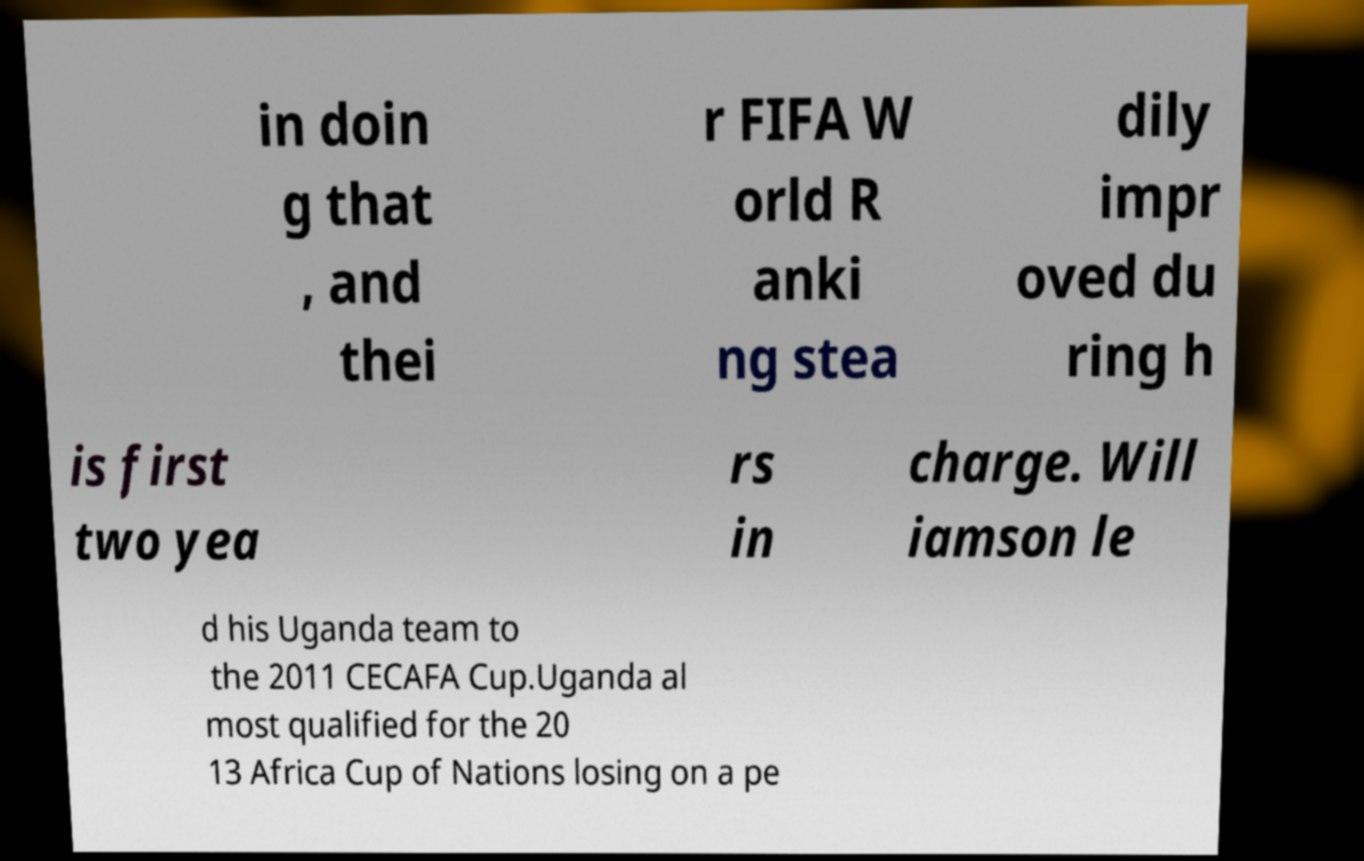Please identify and transcribe the text found in this image. in doin g that , and thei r FIFA W orld R anki ng stea dily impr oved du ring h is first two yea rs in charge. Will iamson le d his Uganda team to the 2011 CECAFA Cup.Uganda al most qualified for the 20 13 Africa Cup of Nations losing on a pe 